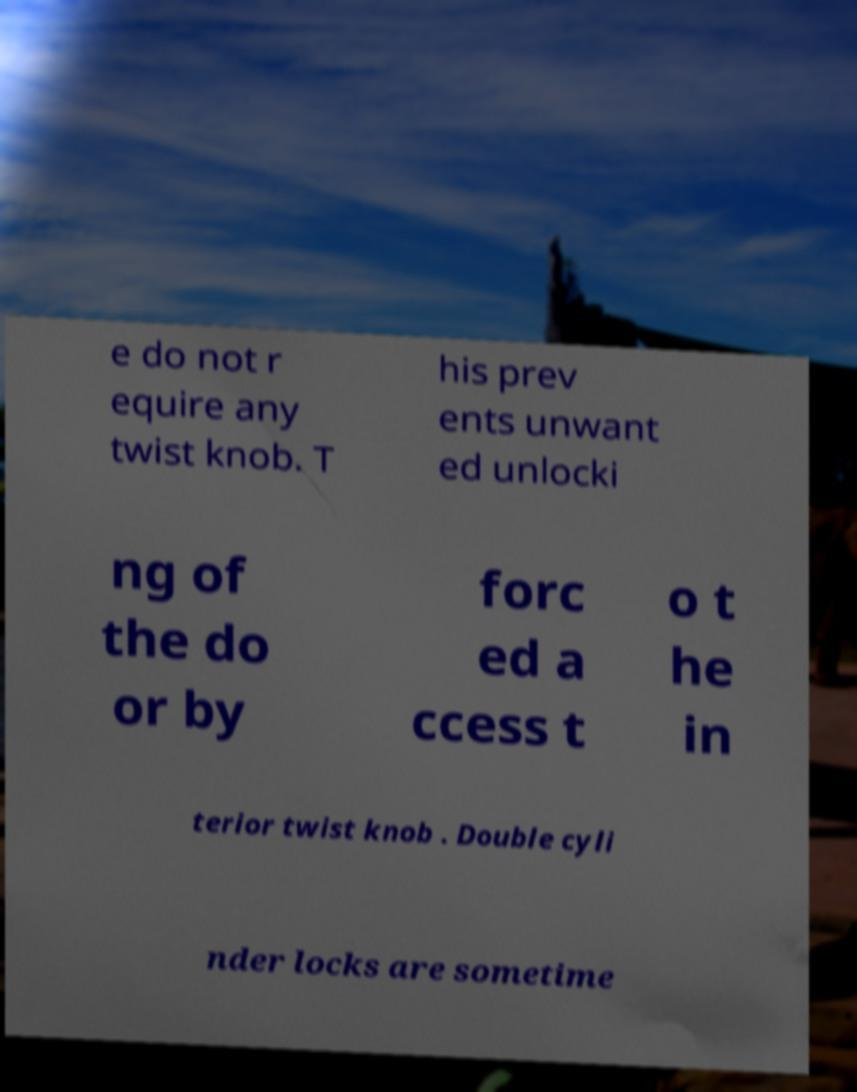I need the written content from this picture converted into text. Can you do that? e do not r equire any twist knob. T his prev ents unwant ed unlocki ng of the do or by forc ed a ccess t o t he in terior twist knob . Double cyli nder locks are sometime 